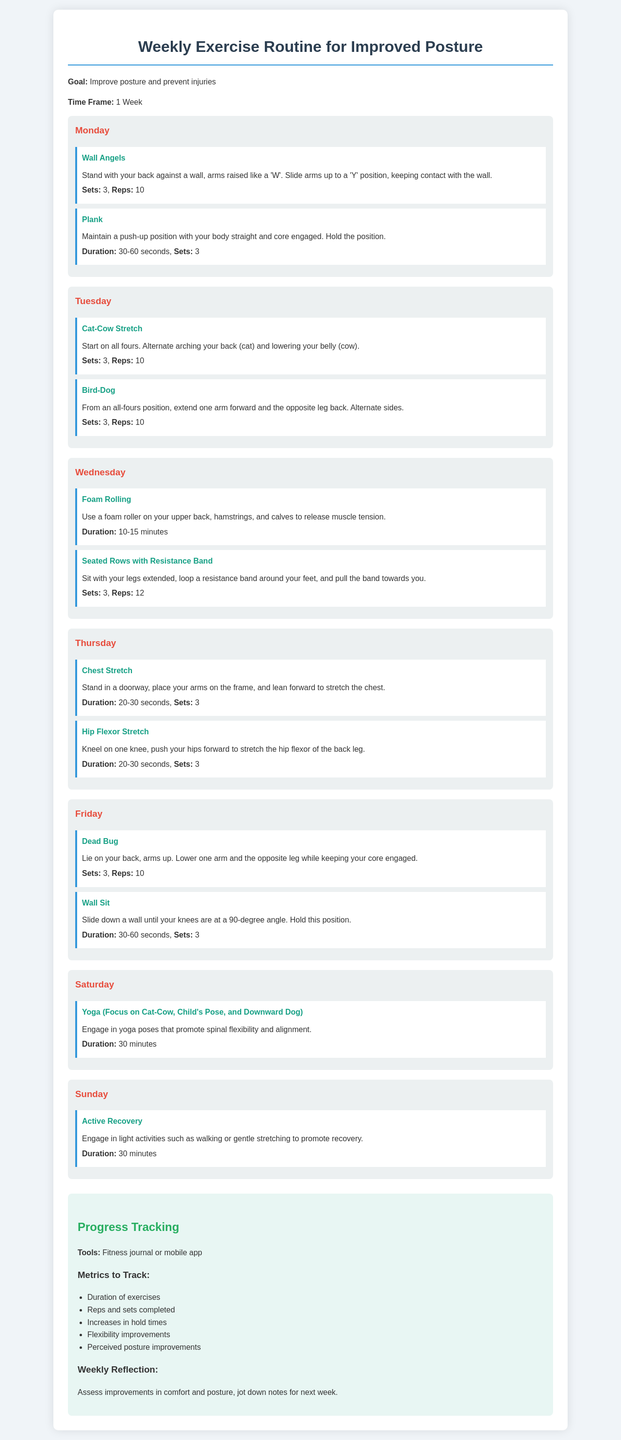What exercises are listed for Monday? The exercises on Monday are Wall Angels and Plank.
Answer: Wall Angels, Plank How many sets of Dead Bug are recommended? The recommended sets for Dead Bug is found in the Friday section, which states 3 sets.
Answer: 3 What is the duration of the Yoga session on Saturday? The duration for the Yoga session is 30 minutes, as stated in the Saturday section.
Answer: 30 minutes What specific muscles does Foam Rolling target according to Wednesday? The Foam Rolling targets upper back, hamstrings, and calves, which are specified in the Wednesday section.
Answer: Upper back, hamstrings, calves What tool can be used for progress tracking? The document mentions a fitness journal or mobile app as tools for progress tracking.
Answer: Fitness journal or mobile app How many reps are suggested for Seated Rows with Resistance Band? The recommended reps for Seated Rows with Resistance Band is 12, as stated in the Wednesday section.
Answer: 12 What is the goal of this exercise routine? The goal of the exercise routine is stated as improving posture and preventing injuries.
Answer: Improve posture and prevent injuries What flexibility improvements should be tracked? The document mentions tracking perceived posture improvements as a metric for progress tracking.
Answer: Perceived posture improvements 